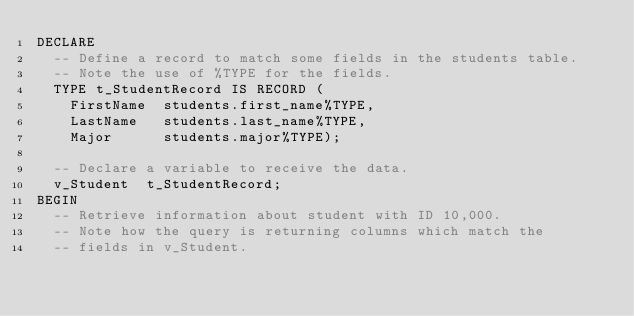<code> <loc_0><loc_0><loc_500><loc_500><_SQL_>DECLARE
  -- Define a record to match some fields in the students table.
  -- Note the use of %TYPE for the fields.
  TYPE t_StudentRecord IS RECORD (
    FirstName  students.first_name%TYPE,
    LastName   students.last_name%TYPE,
    Major      students.major%TYPE);

  -- Declare a variable to receive the data.
  v_Student  t_StudentRecord;
BEGIN
  -- Retrieve information about student with ID 10,000.
  -- Note how the query is returning columns which match the
  -- fields in v_Student.</code> 